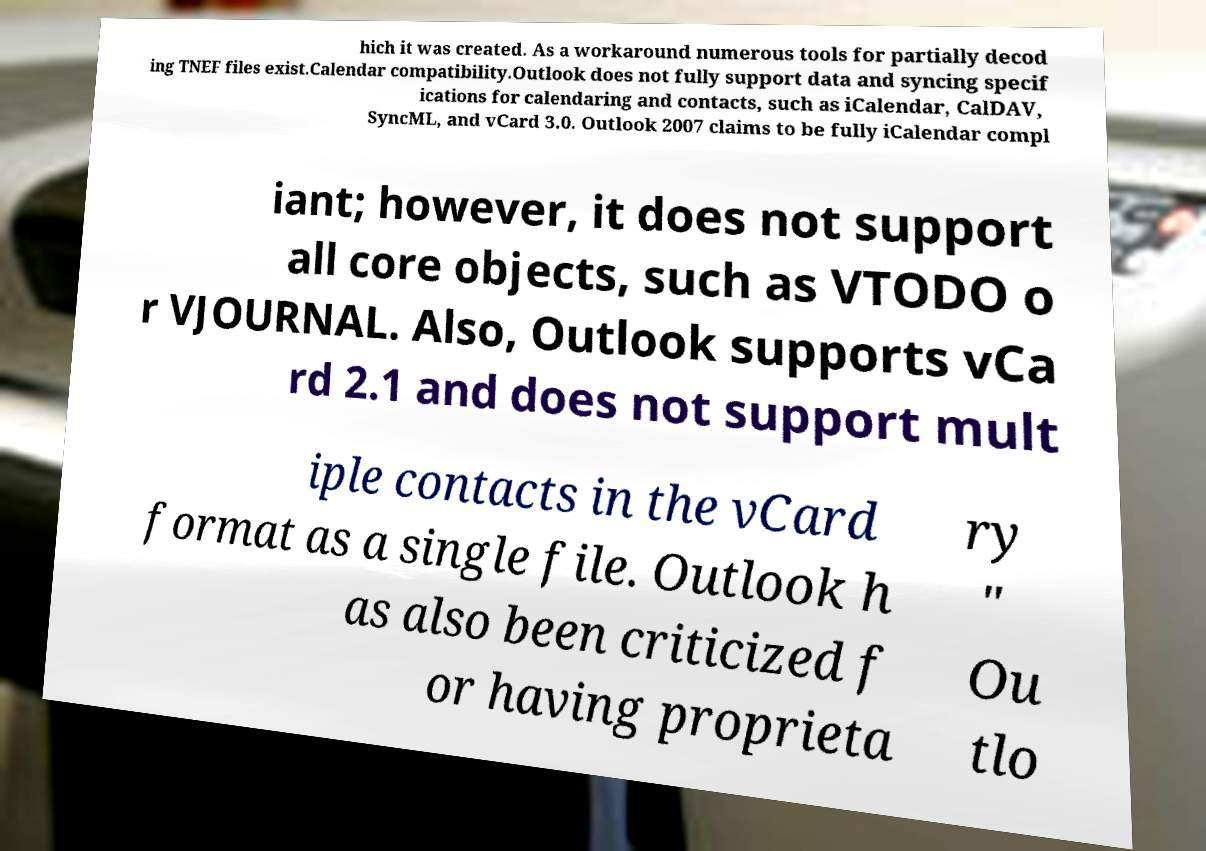Can you accurately transcribe the text from the provided image for me? hich it was created. As a workaround numerous tools for partially decod ing TNEF files exist.Calendar compatibility.Outlook does not fully support data and syncing specif ications for calendaring and contacts, such as iCalendar, CalDAV, SyncML, and vCard 3.0. Outlook 2007 claims to be fully iCalendar compl iant; however, it does not support all core objects, such as VTODO o r VJOURNAL. Also, Outlook supports vCa rd 2.1 and does not support mult iple contacts in the vCard format as a single file. Outlook h as also been criticized f or having proprieta ry " Ou tlo 